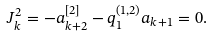<formula> <loc_0><loc_0><loc_500><loc_500>J _ { k } ^ { 2 } = - a _ { k + 2 } ^ { [ 2 ] } - q _ { 1 } ^ { ( 1 , 2 ) } a _ { k + 1 } = 0 .</formula> 